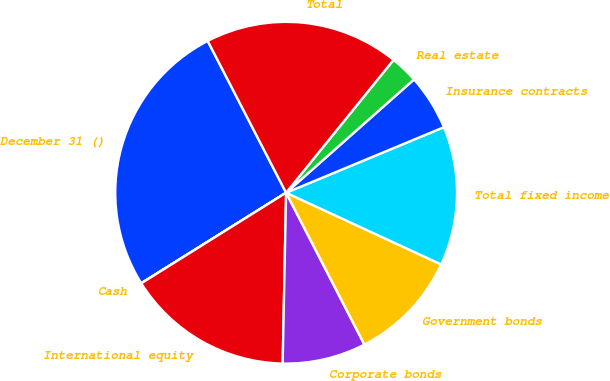Convert chart. <chart><loc_0><loc_0><loc_500><loc_500><pie_chart><fcel>December 31 ()<fcel>Cash<fcel>International equity<fcel>Corporate bonds<fcel>Government bonds<fcel>Total fixed income<fcel>Insurance contracts<fcel>Real estate<fcel>Total<nl><fcel>26.3%<fcel>0.01%<fcel>15.78%<fcel>7.9%<fcel>10.53%<fcel>13.16%<fcel>5.27%<fcel>2.64%<fcel>18.41%<nl></chart> 